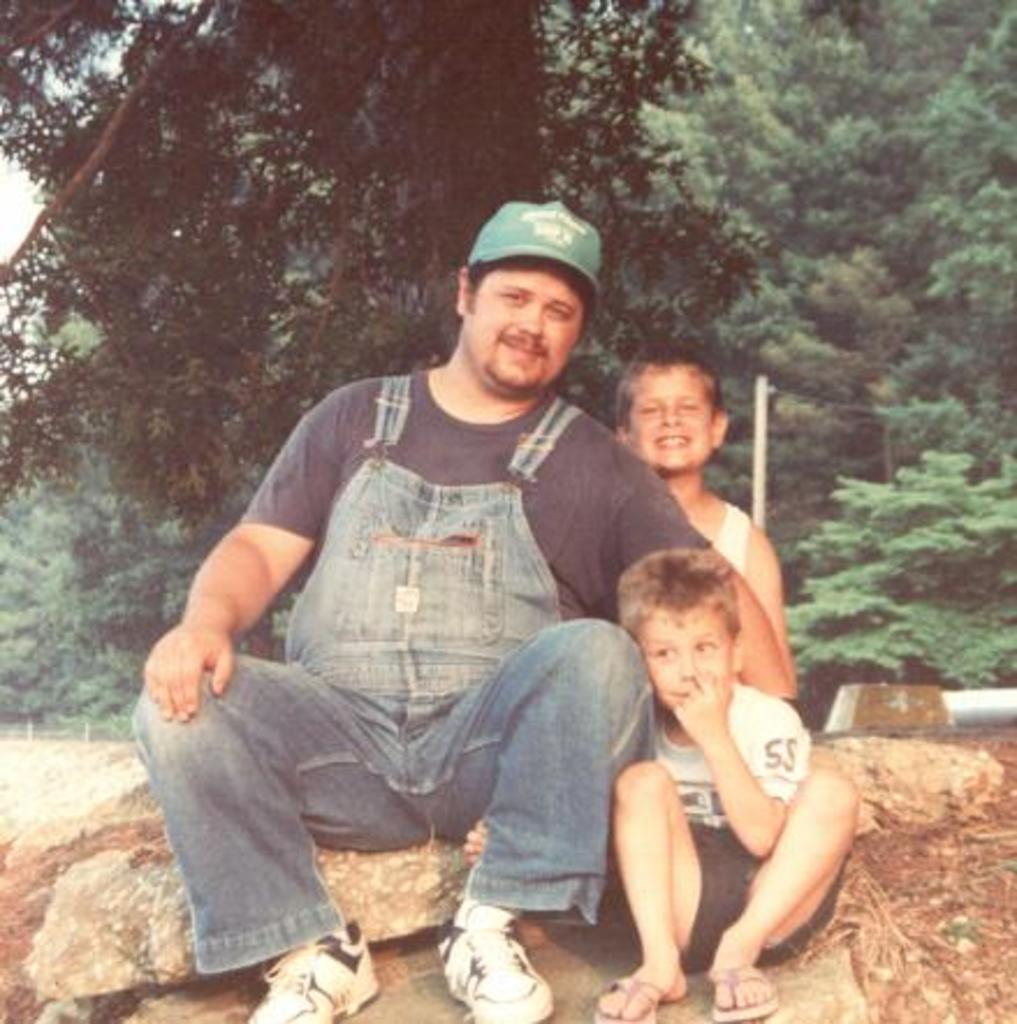How many people are in the image? There are three people in the image. What are the people doing in the image? The people are sitting on rocks. What can be seen in the background of the image? There are trees visible in the background of the image. What type of plane is flying over the people's heads in the image? There is no plane visible in the image; the people are sitting on rocks with trees in the background. 